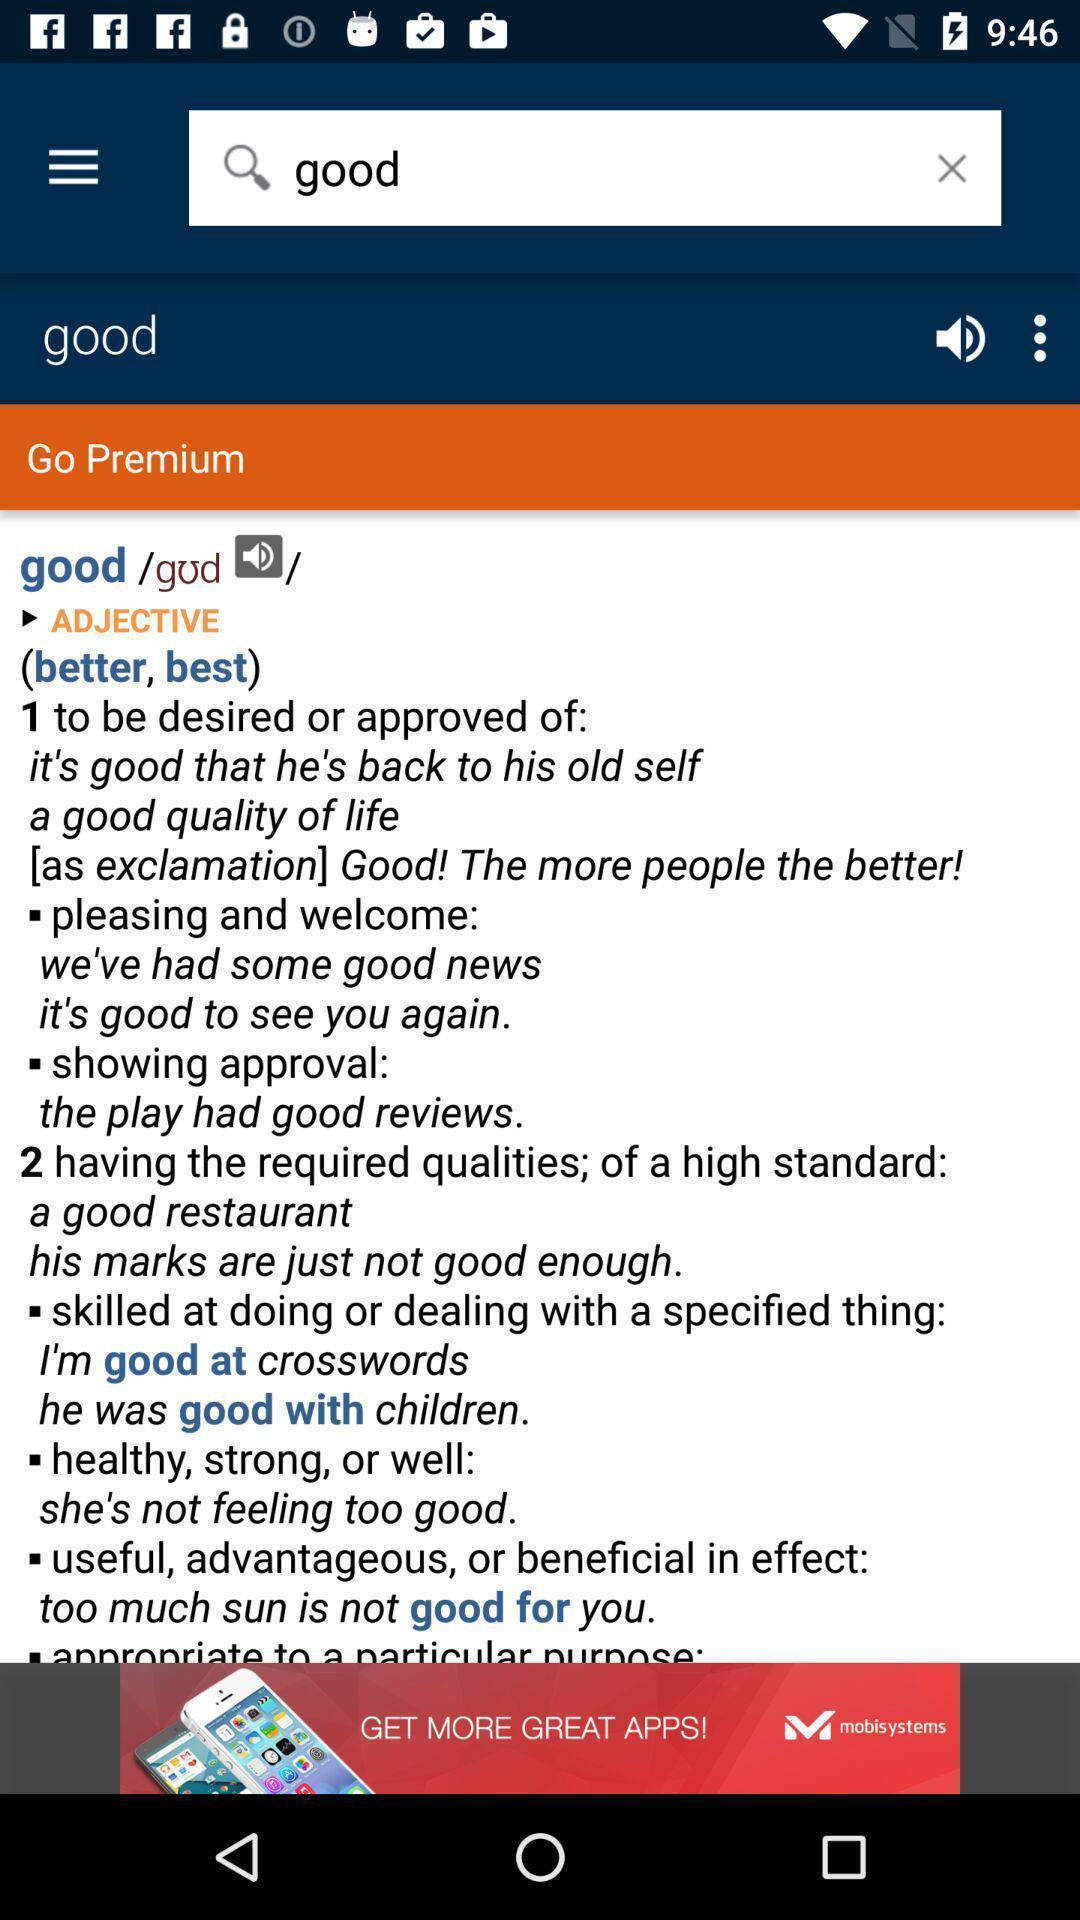Summarize the information in this screenshot. Search bar to find words. 